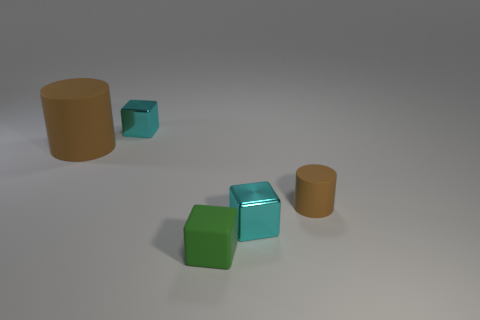What color is the cylinder that is to the right of the small metallic block on the right side of the small rubber block?
Your answer should be compact. Brown. How many other things are made of the same material as the big cylinder?
Offer a very short reply. 2. Is the number of big brown things behind the large brown cylinder the same as the number of big brown matte cylinders?
Your answer should be compact. No. The tiny brown object that is right of the tiny metallic object in front of the small cube that is left of the green cube is made of what material?
Provide a short and direct response. Rubber. There is a matte thing left of the small green matte block; what color is it?
Provide a succinct answer. Brown. What is the size of the cyan shiny block right of the cyan metal cube that is behind the small brown object?
Provide a succinct answer. Small. Is the number of tiny matte cubes left of the tiny green object the same as the number of metallic cubes that are in front of the small brown matte cylinder?
Keep it short and to the point. No. What color is the big thing that is the same material as the small green object?
Provide a succinct answer. Brown. Does the big brown cylinder have the same material as the tiny cylinder that is behind the tiny green rubber cube?
Make the answer very short. Yes. There is a thing that is both on the right side of the big matte cylinder and to the left of the small green rubber cube; what is its color?
Ensure brevity in your answer.  Cyan. 